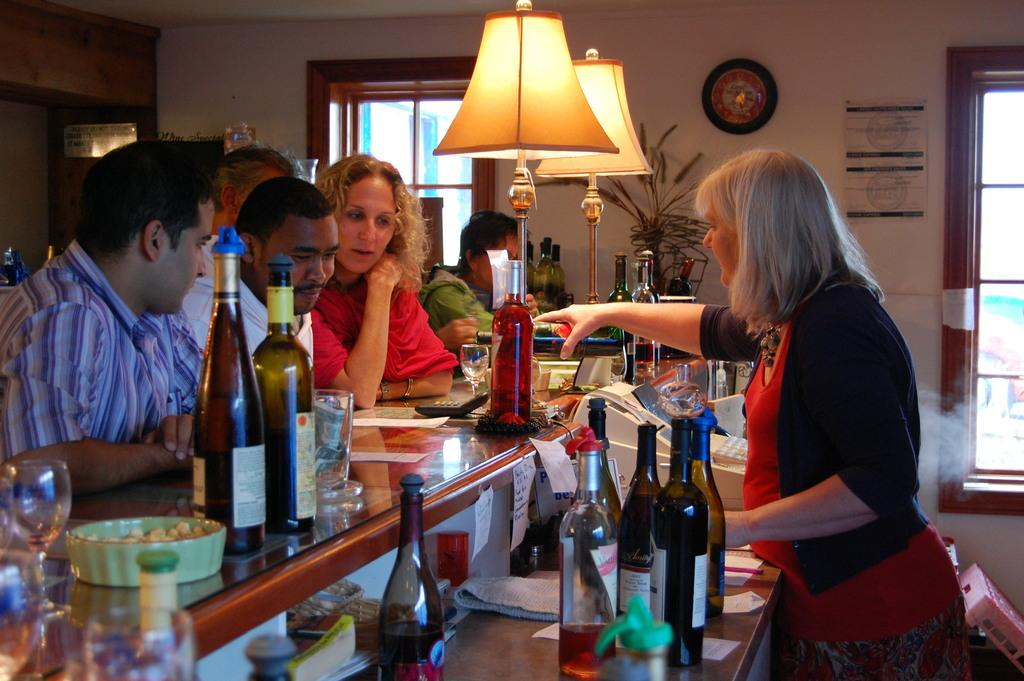Who or what is present in the image? There are people in the image. What objects can be seen on a desk in the image? There are bottles on a desk in the image. What type of lighting is present on a wall in the image? There are lamps on a wall in the image. What time-keeping device is present on a wall in the image? There is a clock on a wall in the image. What type of tableware is present in the image? There are glasses and a plate in the image. What type of sock is being worn by the girls in the image? There are no girls present in the image, and therefore no socks can be observed. What scientific theory is being discussed by the people in the image? The image does not provide any information about a scientific theory being discussed. 